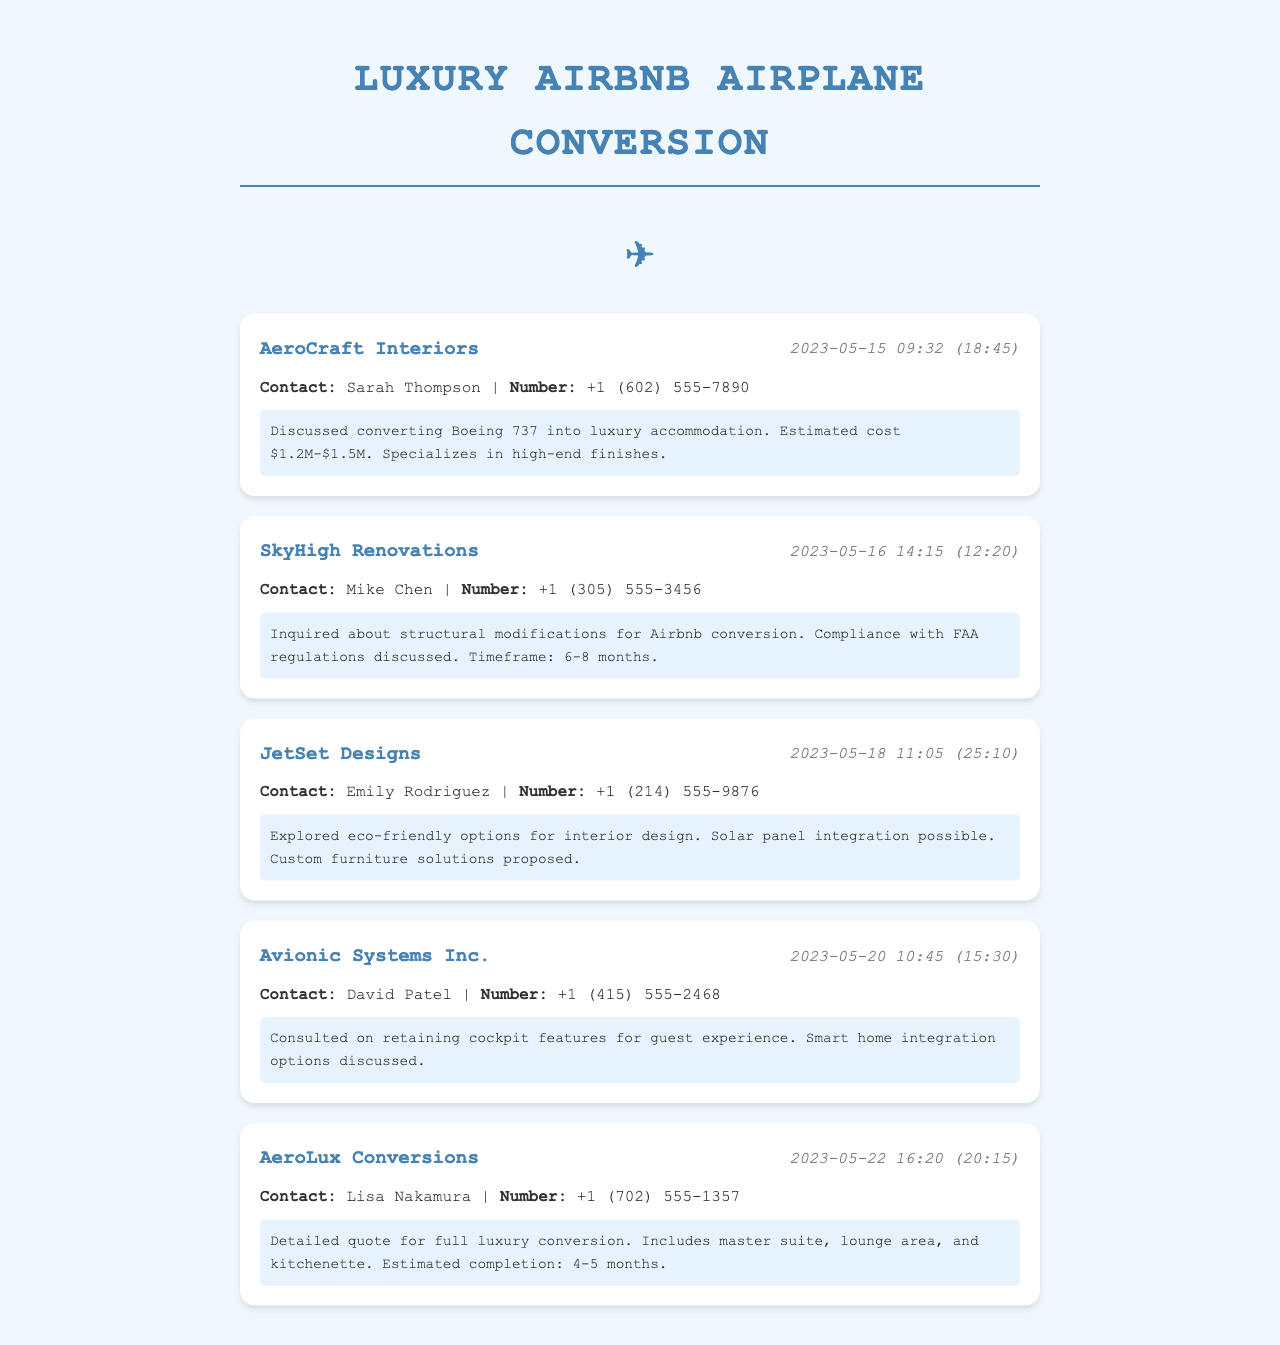what is the name of the first company contacted? The first company mentioned in the call log is AeroCraft Interiors.
Answer: AeroCraft Interiors what was the estimated cost for the Boeing 737 conversion? The call log states the estimated cost for the conversion is $1.2M-$1.5M.
Answer: $1.2M-$1.5M who was the contact person for SkyHigh Renovations? The contact person for SkyHigh Renovations is Mike Chen.
Answer: Mike Chen what compliance topic was discussed with SkyHigh Renovations? Compliance with FAA regulations was discussed during the call.
Answer: FAA regulations how many months is the estimated timeframe for the structural modifications? The estimated timeframe for structural modifications is 6-8 months.
Answer: 6-8 months which company proposed eco-friendly options for interior design? JetSet Designs explored eco-friendly options for interior design.
Answer: JetSet Designs what feature did Avionic Systems Inc. focus on retaining? Avionic Systems Inc. consulted on retaining cockpit features for guest experience.
Answer: cockpit features what does AeroLux Conversions provide in their detailed quote? The detailed quote from AeroLux Conversions includes a master suite, lounge area, and kitchenette.
Answer: master suite, lounge area, and kitchenette which company discussed solar panel integration? The company that discussed solar panel integration is JetSet Designs.
Answer: JetSet Designs 